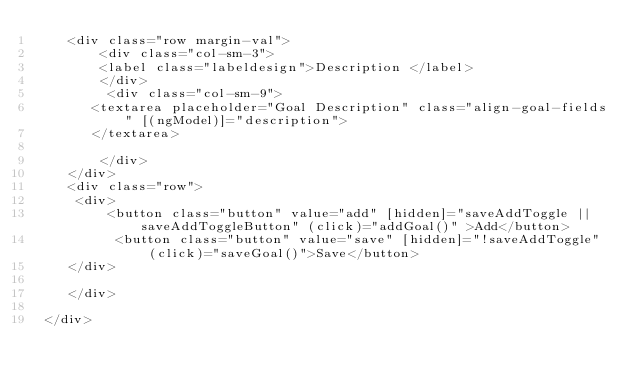<code> <loc_0><loc_0><loc_500><loc_500><_HTML_>    <div class="row margin-val">
        <div class="col-sm-3">
        <label class="labeldesign">Description </label>
        </div>
         <div class="col-sm-9">
       <textarea placeholder="Goal Description" class="align-goal-fields" [(ngModel)]="description">           
       </textarea>
         
        </div>
    </div>
    <div class="row">
     <div>
         <button class="button" value="add" [hidden]="saveAddToggle || saveAddToggleButton" (click)="addGoal()" >Add</button>
          <button class="button" value="save" [hidden]="!saveAddToggle" (click)="saveGoal()">Save</button>
    </div>
 
    </div> 
    
 </div></code> 